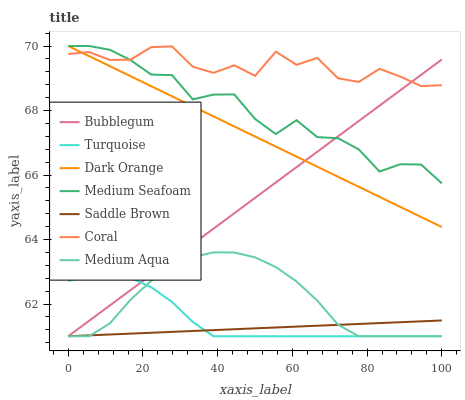Does Saddle Brown have the minimum area under the curve?
Answer yes or no. Yes. Does Coral have the maximum area under the curve?
Answer yes or no. Yes. Does Turquoise have the minimum area under the curve?
Answer yes or no. No. Does Turquoise have the maximum area under the curve?
Answer yes or no. No. Is Saddle Brown the smoothest?
Answer yes or no. Yes. Is Coral the roughest?
Answer yes or no. Yes. Is Turquoise the smoothest?
Answer yes or no. No. Is Turquoise the roughest?
Answer yes or no. No. Does Turquoise have the lowest value?
Answer yes or no. Yes. Does Coral have the lowest value?
Answer yes or no. No. Does Medium Seafoam have the highest value?
Answer yes or no. Yes. Does Turquoise have the highest value?
Answer yes or no. No. Is Saddle Brown less than Medium Seafoam?
Answer yes or no. Yes. Is Dark Orange greater than Medium Aqua?
Answer yes or no. Yes. Does Bubblegum intersect Turquoise?
Answer yes or no. Yes. Is Bubblegum less than Turquoise?
Answer yes or no. No. Is Bubblegum greater than Turquoise?
Answer yes or no. No. Does Saddle Brown intersect Medium Seafoam?
Answer yes or no. No. 